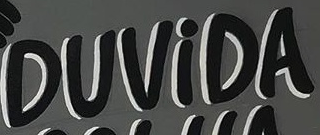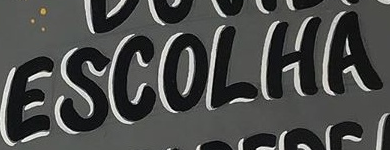What text is displayed in these images sequentially, separated by a semicolon? DUViDA; ESCOLHA 